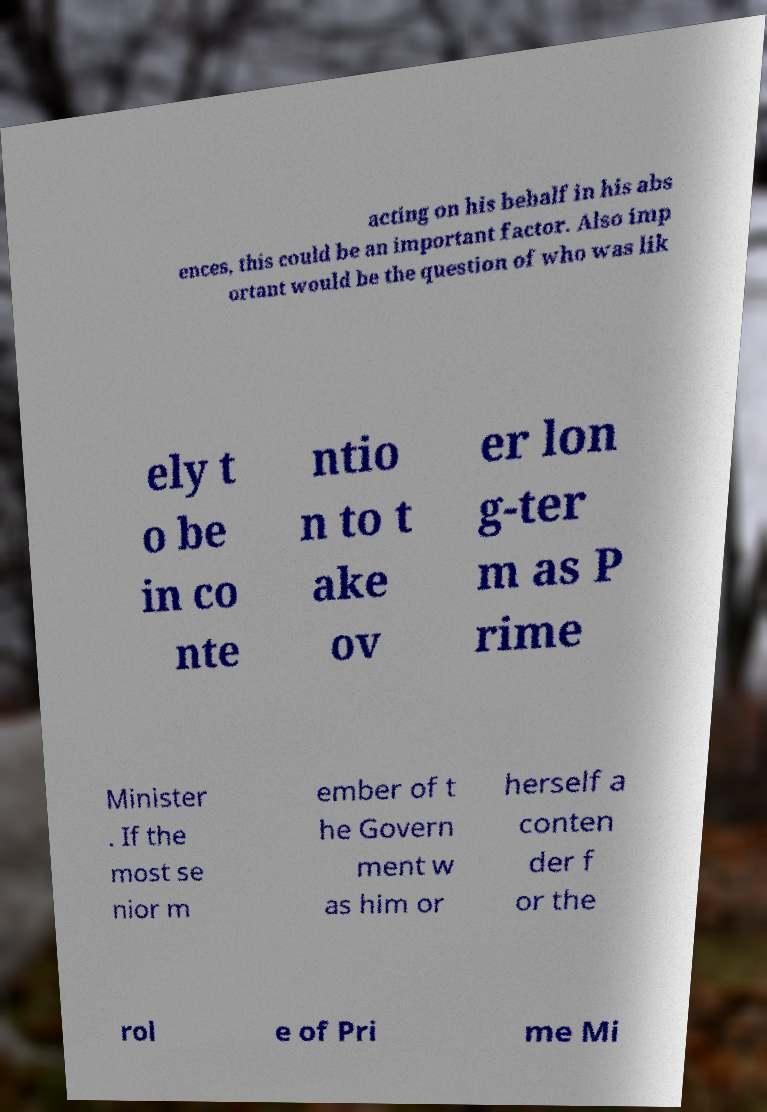Please identify and transcribe the text found in this image. acting on his behalf in his abs ences, this could be an important factor. Also imp ortant would be the question of who was lik ely t o be in co nte ntio n to t ake ov er lon g-ter m as P rime Minister . If the most se nior m ember of t he Govern ment w as him or herself a conten der f or the rol e of Pri me Mi 